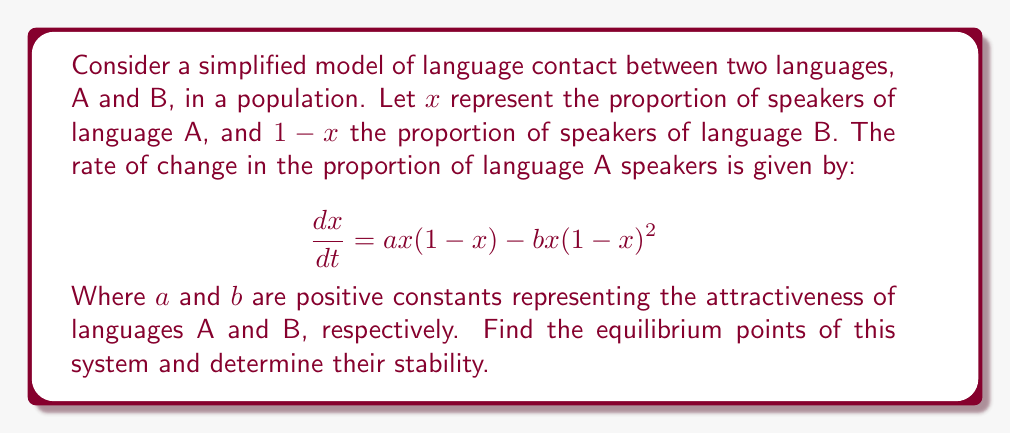Teach me how to tackle this problem. To solve this problem, we'll follow these steps:

1) Find the equilibrium points by setting $\frac{dx}{dt} = 0$:

   $$ax(1-x) - bx(1-x)^2 = 0$$

2) Factor out $x$:

   $$x[a(1-x) - b(1-x)^2] = 0$$

3) Solve for $x$:
   
   $x = 0$ is one solution.
   For the other solution(s), solve $a(1-x) - b(1-x)^2 = 0$
   
   $$a - ax - b + 2bx - bx^2 = 0$$
   $$bx^2 + (a-2b)x + (b-a) = 0$$

4) Using the quadratic formula, we get:

   $$x = \frac{(2b-a) \pm \sqrt{(a-2b)^2 - 4b(b-a)}}{2b}$$

   $$x = \frac{(2b-a) \pm \sqrt{a^2-4ab+4b^2}}{2b}$$

   $$x = 1 - \frac{a}{2b} \pm \frac{\sqrt{a^2-4ab+4b^2}}{2b}$$

5) To determine stability, we need to find $\frac{d}{dx}(\frac{dx}{dt})$ at each equilibrium point:

   $$\frac{d}{dx}(\frac{dx}{dt}) = a(1-2x) - b(1-x)^2 + 2bx(1-x)$$

6) At $x = 0$:
   
   $$\frac{d}{dx}(\frac{dx}{dt})|_{x=0} = a - b$$

   If $a > b$, this equilibrium is unstable. If $a < b$, it's stable.

7) At $x = 1 - \frac{a}{2b} \pm \frac{\sqrt{a^2-4ab+4b^2}}{2b}$:

   The stability depends on the sign of $\frac{d}{dx}(\frac{dx}{dt})$ at this point. If it's negative, the equilibrium is stable; if positive, it's unstable.
Answer: Equilibrium points: $x = 0$ and $x = 1 - \frac{a}{2b} \pm \frac{\sqrt{a^2-4ab+4b^2}}{2b}$. Stability depends on values of $a$ and $b$. 